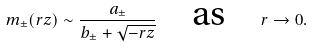<formula> <loc_0><loc_0><loc_500><loc_500>m _ { \pm } ( r z ) \sim \frac { a _ { \pm } } { b _ { \pm } + \sqrt { - r z } } \quad \text {as} \quad r \to 0 .</formula> 